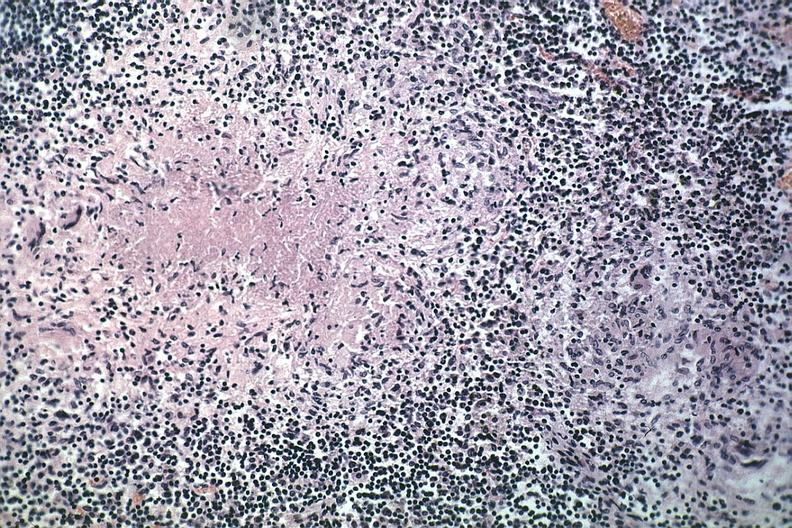s lymph node present?
Answer the question using a single word or phrase. Yes 